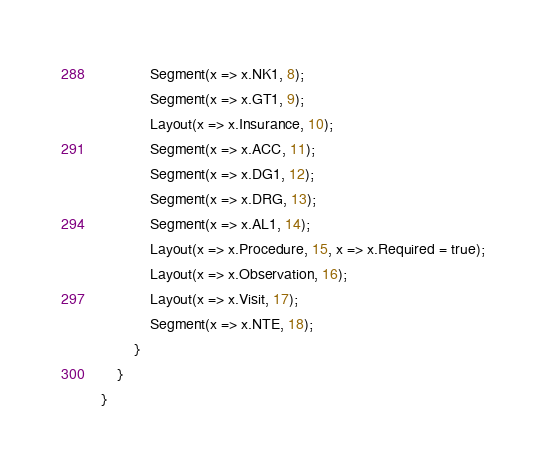Convert code to text. <code><loc_0><loc_0><loc_500><loc_500><_C#_>            Segment(x => x.NK1, 8);
            Segment(x => x.GT1, 9);
            Layout(x => x.Insurance, 10);
            Segment(x => x.ACC, 11);
            Segment(x => x.DG1, 12);
            Segment(x => x.DRG, 13);
            Segment(x => x.AL1, 14);
            Layout(x => x.Procedure, 15, x => x.Required = true);
            Layout(x => x.Observation, 16);
            Layout(x => x.Visit, 17);
            Segment(x => x.NTE, 18);
        }
    }
}</code> 